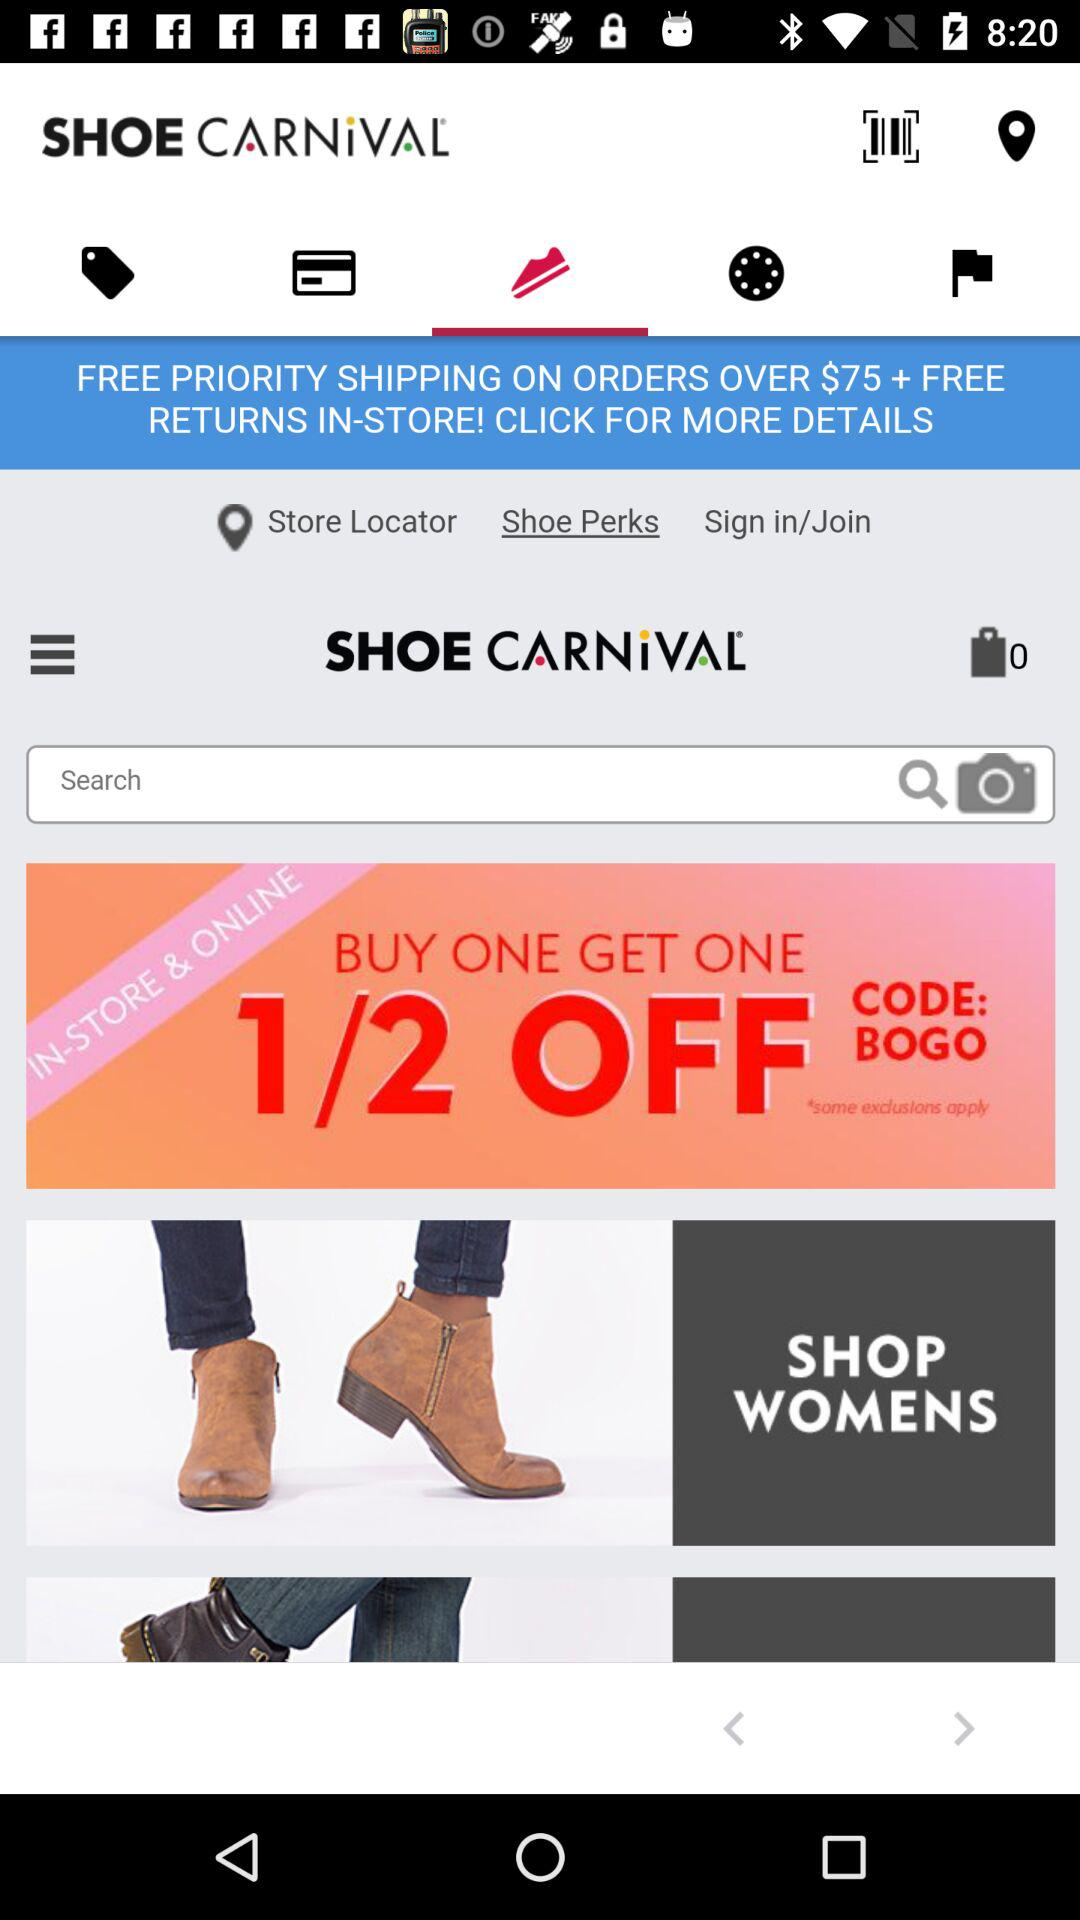What should be Minimum Order cost to avail the FREE PRIORITYSHIPPING?
When the provided information is insufficient, respond with <no answer>. <no answer> 